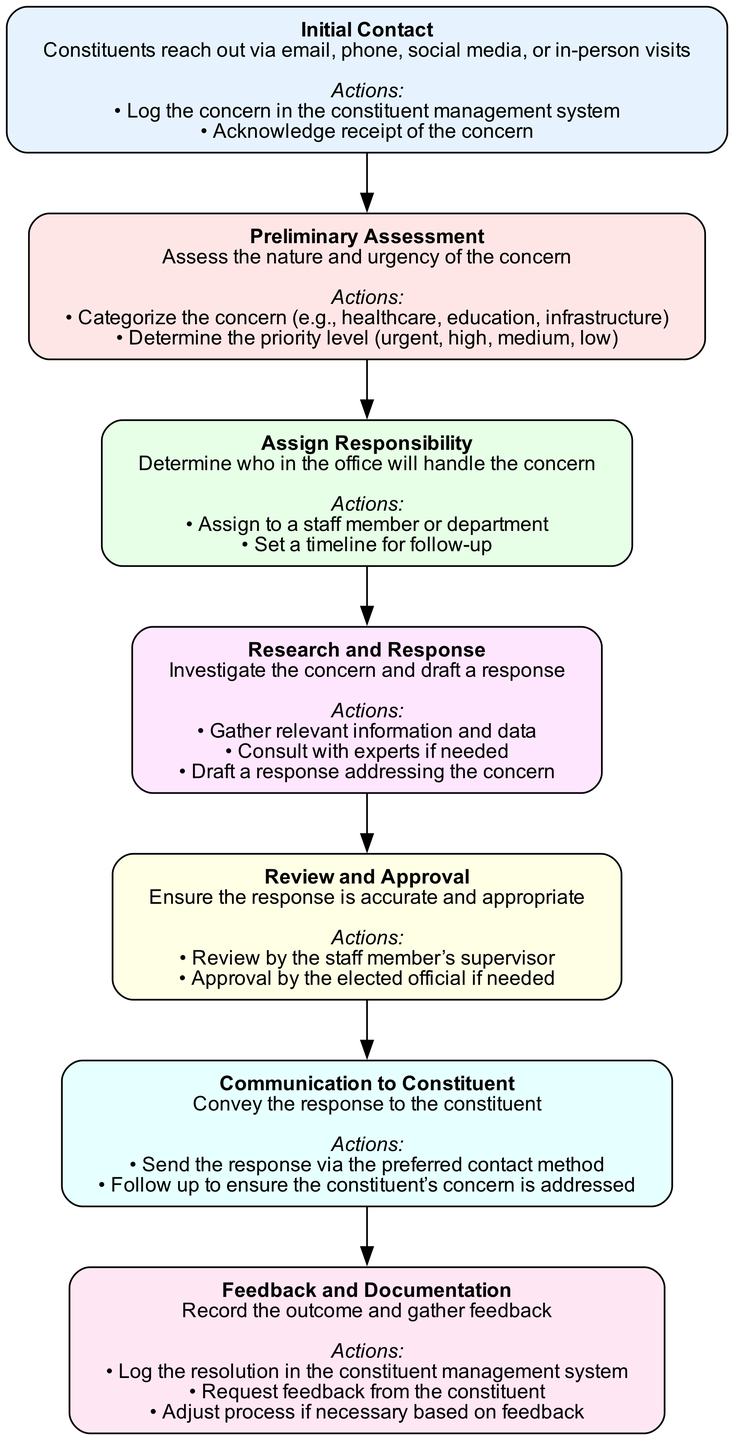What is the first stage in the process? The first stage listed in the diagram is "Initial Contact." I identify it by looking at the order of the stages starting from the top.
Answer: Initial Contact How many actions are listed under "Research and Response"? To answer this, I check the "Research and Response" stage and count the actions provided. There are three distinct actions mentioned under this stage.
Answer: 3 What is the last action in the "Feedback and Documentation" stage? I refer to the listed actions in the "Feedback and Documentation" stage and look for the last action. The last action listed is "Adjust process if necessary based on feedback."
Answer: Adjust process if necessary based on feedback Which stage comes immediately after "Preliminary Assessment"? Looking at the flow of the diagram, I see that "Assign Responsibility" follows "Preliminary Assessment." I identify the direct connection between these two stages.
Answer: Assign Responsibility What category is included in the preliminary assessment actions? I check the actions listed under "Preliminary Assessment" and find that "Categorize the concern (e.g., healthcare, education, infrastructure)" is presented as one of the actions.
Answer: Categorize the concern (e.g., healthcare, education, infrastructure) What stage requires review by the staff member's supervisor? In the diagram, the "Review and Approval" stage specifically mentions that the response needs to be reviewed by the staff member’s supervisor. Thus, I can confidently identify this stage as the answer.
Answer: Review and Approval How many total stages are represented in the flowchart? I count the stages listed in the data provided. There are a total of seven stages outlined in the flowchart, starting from "Initial Contact" to "Feedback and Documentation."
Answer: 7 What is the last stage in the process? By examining the order of the stages from top to bottom, I see that the last stage is "Feedback and Documentation." This is clearly the final part of the process.
Answer: Feedback and Documentation Which action is taken to address urgency and priority in the second stage? In the "Preliminary Assessment" stage, one of the actions is "Determine the priority level (urgent, high, medium, low)." This addresses the urgency and priority of the concern.
Answer: Determine the priority level (urgent, high, medium, low) 